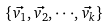Convert formula to latex. <formula><loc_0><loc_0><loc_500><loc_500>\{ \vec { v _ { 1 } } , \vec { v _ { 2 } } , \cdot \cdot \cdot , \vec { v _ { k } } \}</formula> 